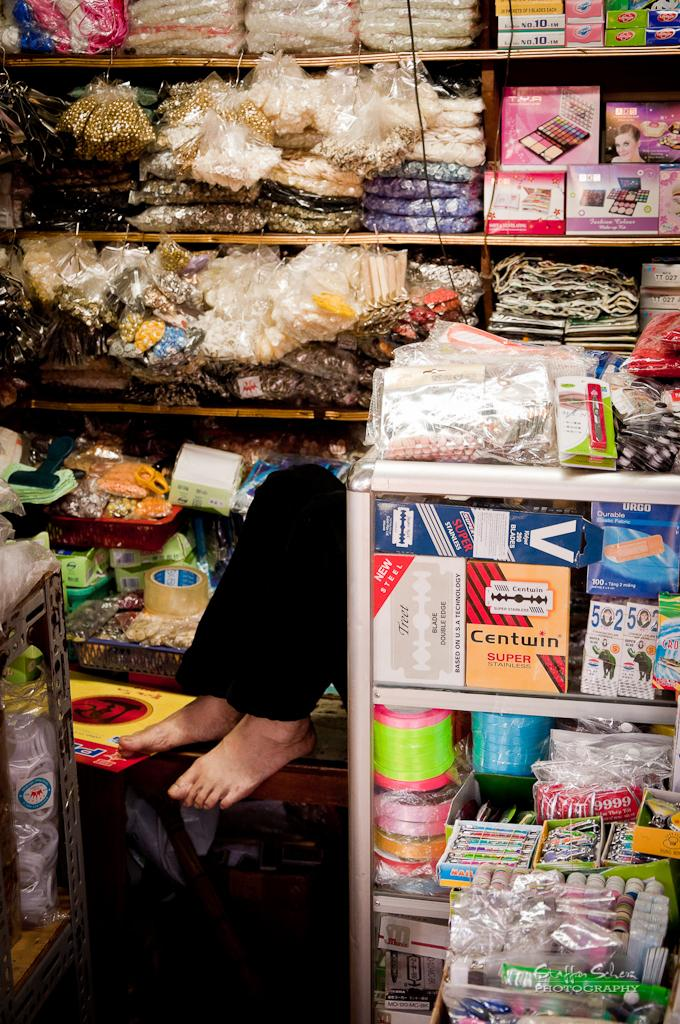<image>
Provide a brief description of the given image. a pair of legs and feet sticking out from an over stuffed display case with things like Centwin 